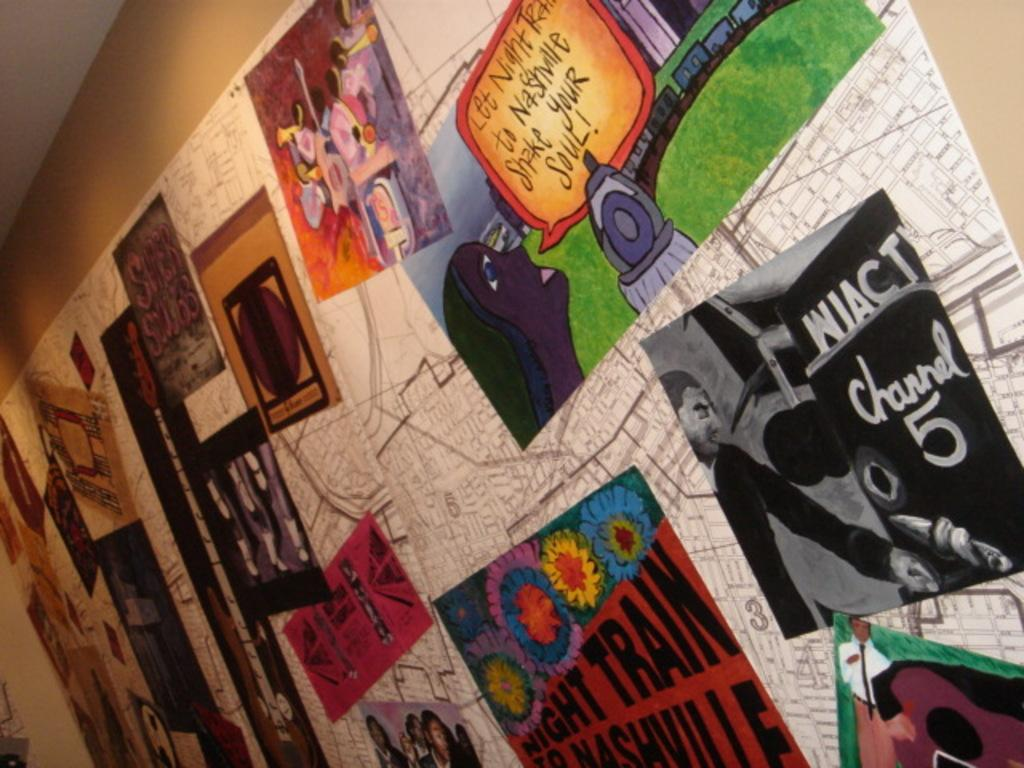<image>
Offer a succinct explanation of the picture presented. Wall with pictures on it and one saying " Let Night Train to Nashville Shake Your Soul". 